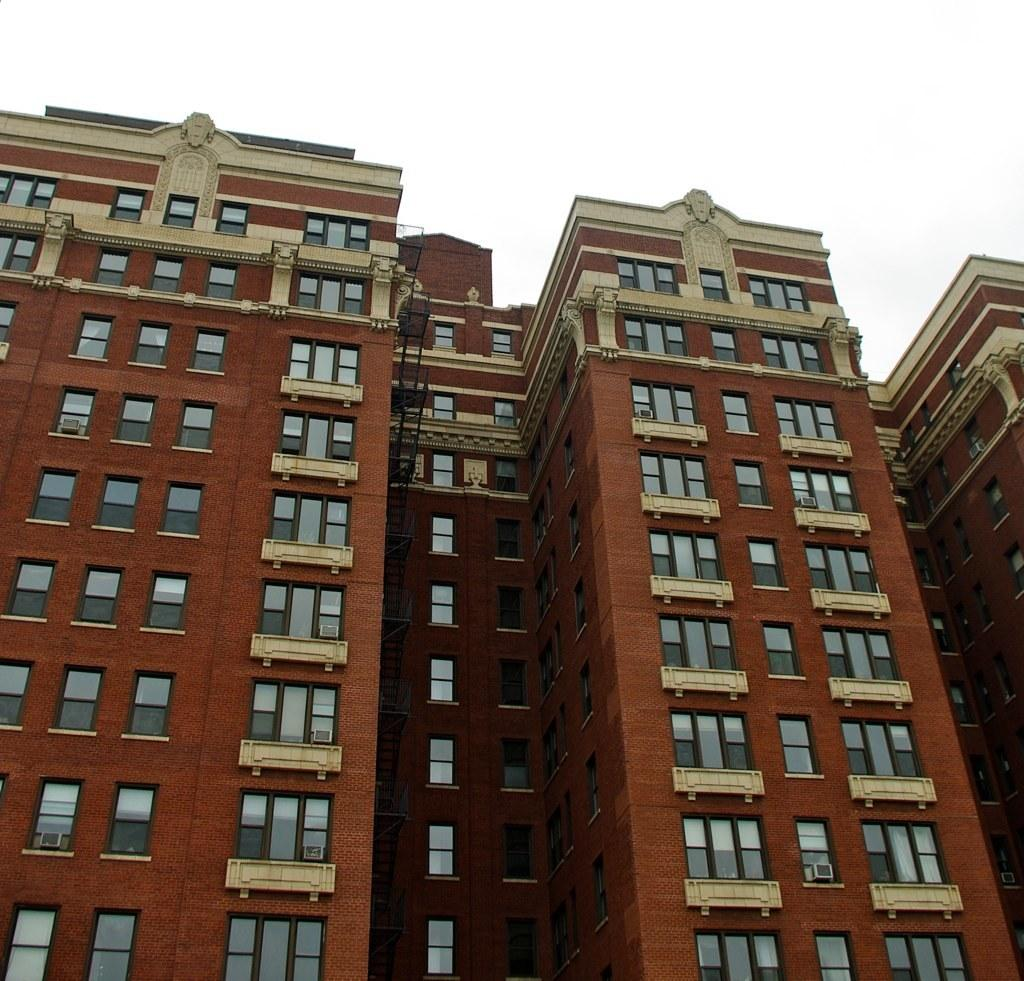What is the main subject in the center of the image? There are buildings in the center of the image. What can be seen at the top of the image? The sky is visible at the top of the image. How many men are enjoying their vacation in the image? There is no reference to men or a vacation in the image, so it is not possible to answer that question. 